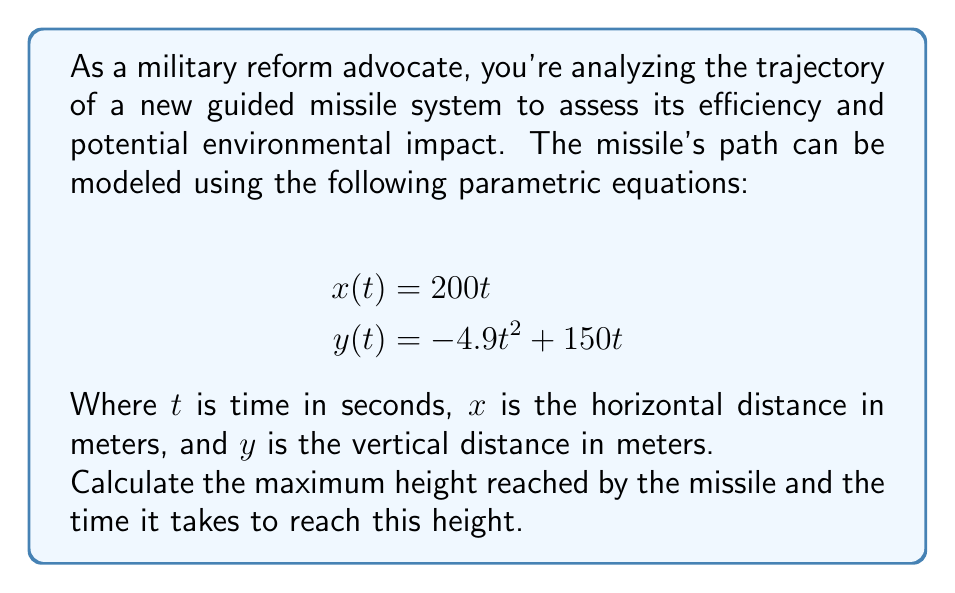What is the answer to this math problem? To solve this problem, we'll follow these steps:

1) The maximum height occurs when the vertical velocity is zero. We can find this by taking the derivative of $y(t)$ with respect to $t$ and setting it equal to zero.

2) The derivative of $y(t)$ is:
   $$y'(t) = -9.8t + 150$$

3) Set this equal to zero and solve for $t$:
   $$-9.8t + 150 = 0$$
   $$9.8t = 150$$
   $$t = \frac{150}{9.8} \approx 15.31 \text{ seconds}$$

4) This is the time at which the missile reaches its maximum height.

5) To find the maximum height, we substitute this $t$ value back into the original equation for $y(t)$:

   $$y(15.31) = -4.9(15.31)^2 + 150(15.31)$$
   $$= -4.9(234.3961) + 2296.5$$
   $$= -1148.5409 + 2296.5$$
   $$\approx 1147.96 \text{ meters}$$

Therefore, the missile reaches its maximum height of approximately 1147.96 meters after about 15.31 seconds.
Answer: Maximum height: 1147.96 meters
Time to reach maximum height: 15.31 seconds 